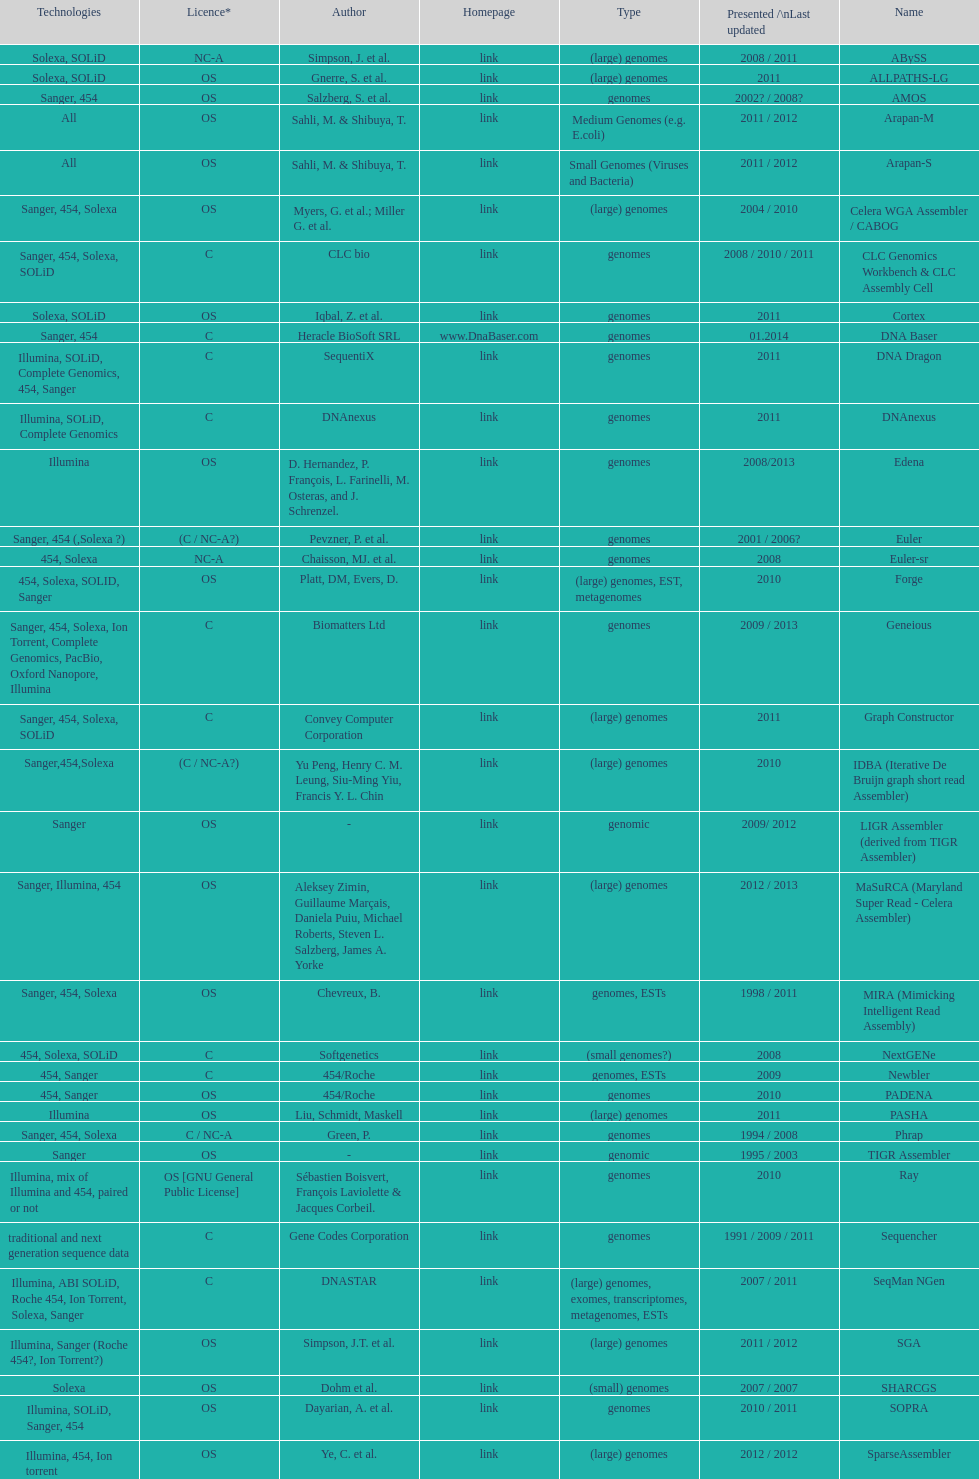Which license is listed more, os or c? OS. Give me the full table as a dictionary. {'header': ['Technologies', 'Licence*', 'Author', 'Homepage', 'Type', 'Presented /\\nLast updated', 'Name'], 'rows': [['Solexa, SOLiD', 'NC-A', 'Simpson, J. et al.', 'link', '(large) genomes', '2008 / 2011', 'ABySS'], ['Solexa, SOLiD', 'OS', 'Gnerre, S. et al.', 'link', '(large) genomes', '2011', 'ALLPATHS-LG'], ['Sanger, 454', 'OS', 'Salzberg, S. et al.', 'link', 'genomes', '2002? / 2008?', 'AMOS'], ['All', 'OS', 'Sahli, M. & Shibuya, T.', 'link', 'Medium Genomes (e.g. E.coli)', '2011 / 2012', 'Arapan-M'], ['All', 'OS', 'Sahli, M. & Shibuya, T.', 'link', 'Small Genomes (Viruses and Bacteria)', '2011 / 2012', 'Arapan-S'], ['Sanger, 454, Solexa', 'OS', 'Myers, G. et al.; Miller G. et al.', 'link', '(large) genomes', '2004 / 2010', 'Celera WGA Assembler / CABOG'], ['Sanger, 454, Solexa, SOLiD', 'C', 'CLC bio', 'link', 'genomes', '2008 / 2010 / 2011', 'CLC Genomics Workbench & CLC Assembly Cell'], ['Solexa, SOLiD', 'OS', 'Iqbal, Z. et al.', 'link', 'genomes', '2011', 'Cortex'], ['Sanger, 454', 'C', 'Heracle BioSoft SRL', 'www.DnaBaser.com', 'genomes', '01.2014', 'DNA Baser'], ['Illumina, SOLiD, Complete Genomics, 454, Sanger', 'C', 'SequentiX', 'link', 'genomes', '2011', 'DNA Dragon'], ['Illumina, SOLiD, Complete Genomics', 'C', 'DNAnexus', 'link', 'genomes', '2011', 'DNAnexus'], ['Illumina', 'OS', 'D. Hernandez, P. François, L. Farinelli, M. Osteras, and J. Schrenzel.', 'link', 'genomes', '2008/2013', 'Edena'], ['Sanger, 454 (,Solexa\xa0?)', '(C / NC-A?)', 'Pevzner, P. et al.', 'link', 'genomes', '2001 / 2006?', 'Euler'], ['454, Solexa', 'NC-A', 'Chaisson, MJ. et al.', 'link', 'genomes', '2008', 'Euler-sr'], ['454, Solexa, SOLID, Sanger', 'OS', 'Platt, DM, Evers, D.', 'link', '(large) genomes, EST, metagenomes', '2010', 'Forge'], ['Sanger, 454, Solexa, Ion Torrent, Complete Genomics, PacBio, Oxford Nanopore, Illumina', 'C', 'Biomatters Ltd', 'link', 'genomes', '2009 / 2013', 'Geneious'], ['Sanger, 454, Solexa, SOLiD', 'C', 'Convey Computer Corporation', 'link', '(large) genomes', '2011', 'Graph Constructor'], ['Sanger,454,Solexa', '(C / NC-A?)', 'Yu Peng, Henry C. M. Leung, Siu-Ming Yiu, Francis Y. L. Chin', 'link', '(large) genomes', '2010', 'IDBA (Iterative De Bruijn graph short read Assembler)'], ['Sanger', 'OS', '-', 'link', 'genomic', '2009/ 2012', 'LIGR Assembler (derived from TIGR Assembler)'], ['Sanger, Illumina, 454', 'OS', 'Aleksey Zimin, Guillaume Marçais, Daniela Puiu, Michael Roberts, Steven L. Salzberg, James A. Yorke', 'link', '(large) genomes', '2012 / 2013', 'MaSuRCA (Maryland Super Read - Celera Assembler)'], ['Sanger, 454, Solexa', 'OS', 'Chevreux, B.', 'link', 'genomes, ESTs', '1998 / 2011', 'MIRA (Mimicking Intelligent Read Assembly)'], ['454, Solexa, SOLiD', 'C', 'Softgenetics', 'link', '(small genomes?)', '2008', 'NextGENe'], ['454, Sanger', 'C', '454/Roche', 'link', 'genomes, ESTs', '2009', 'Newbler'], ['454, Sanger', 'OS', '454/Roche', 'link', 'genomes', '2010', 'PADENA'], ['Illumina', 'OS', 'Liu, Schmidt, Maskell', 'link', '(large) genomes', '2011', 'PASHA'], ['Sanger, 454, Solexa', 'C / NC-A', 'Green, P.', 'link', 'genomes', '1994 / 2008', 'Phrap'], ['Sanger', 'OS', '-', 'link', 'genomic', '1995 / 2003', 'TIGR Assembler'], ['Illumina, mix of Illumina and 454, paired or not', 'OS [GNU General Public License]', 'Sébastien Boisvert, François Laviolette & Jacques Corbeil.', 'link', 'genomes', '2010', 'Ray'], ['traditional and next generation sequence data', 'C', 'Gene Codes Corporation', 'link', 'genomes', '1991 / 2009 / 2011', 'Sequencher'], ['Illumina, ABI SOLiD, Roche 454, Ion Torrent, Solexa, Sanger', 'C', 'DNASTAR', 'link', '(large) genomes, exomes, transcriptomes, metagenomes, ESTs', '2007 / 2011', 'SeqMan NGen'], ['Illumina, Sanger (Roche 454?, Ion Torrent?)', 'OS', 'Simpson, J.T. et al.', 'link', '(large) genomes', '2011 / 2012', 'SGA'], ['Solexa', 'OS', 'Dohm et al.', 'link', '(small) genomes', '2007 / 2007', 'SHARCGS'], ['Illumina, SOLiD, Sanger, 454', 'OS', 'Dayarian, A. et al.', 'link', 'genomes', '2010 / 2011', 'SOPRA'], ['Illumina, 454, Ion torrent', 'OS', 'Ye, C. et al.', 'link', '(large) genomes', '2012 / 2012', 'SparseAssembler'], ['Solexa (SOLiD? Helicos?)', 'OS', 'Warren, R. et al.', 'link', '(small) genomes', '2007 / 2007', 'SSAKE'], ['Solexa', 'OS', 'Li, R. et al.', 'link', 'genomes', '2009 / 2009', 'SOAPdenovo'], ['Illumina, Solexa', 'OS', 'Bankevich, A et al.', 'link', '(small) genomes, single-cell', '2012 / 2013', 'SPAdes'], ['Sanger', 'OS', 'Staden et al.', 'link', 'BACs (, small genomes?)', '1991 / 2008', 'Staden gap4 package'], ['Illumina', 'OS', 'Schmidt, B. et al.', 'link', '(small) genomes', '2009', 'Taipan'], ['Solexa (SOLiD?, Helicos?)', 'OS', 'Jeck, W. et al.', 'link', '(small) genomes', '2007 / 2007', 'VCAKE'], ['Sanger', 'OS', 'Mullikin JC, et al.', 'link', '(large) genomes', '2003', 'Phusion assembler'], ['Sanger, Solexa', 'OS', 'Bryant DW, et al.', 'link', 'genomes', '2009', 'Quality Value Guided SRA (QSRA)'], ['Sanger, 454, Solexa, SOLiD', 'OS', 'Zerbino, D. et al.', 'link', '(small) genomes', '2007 / 2009', 'Velvet']]} 